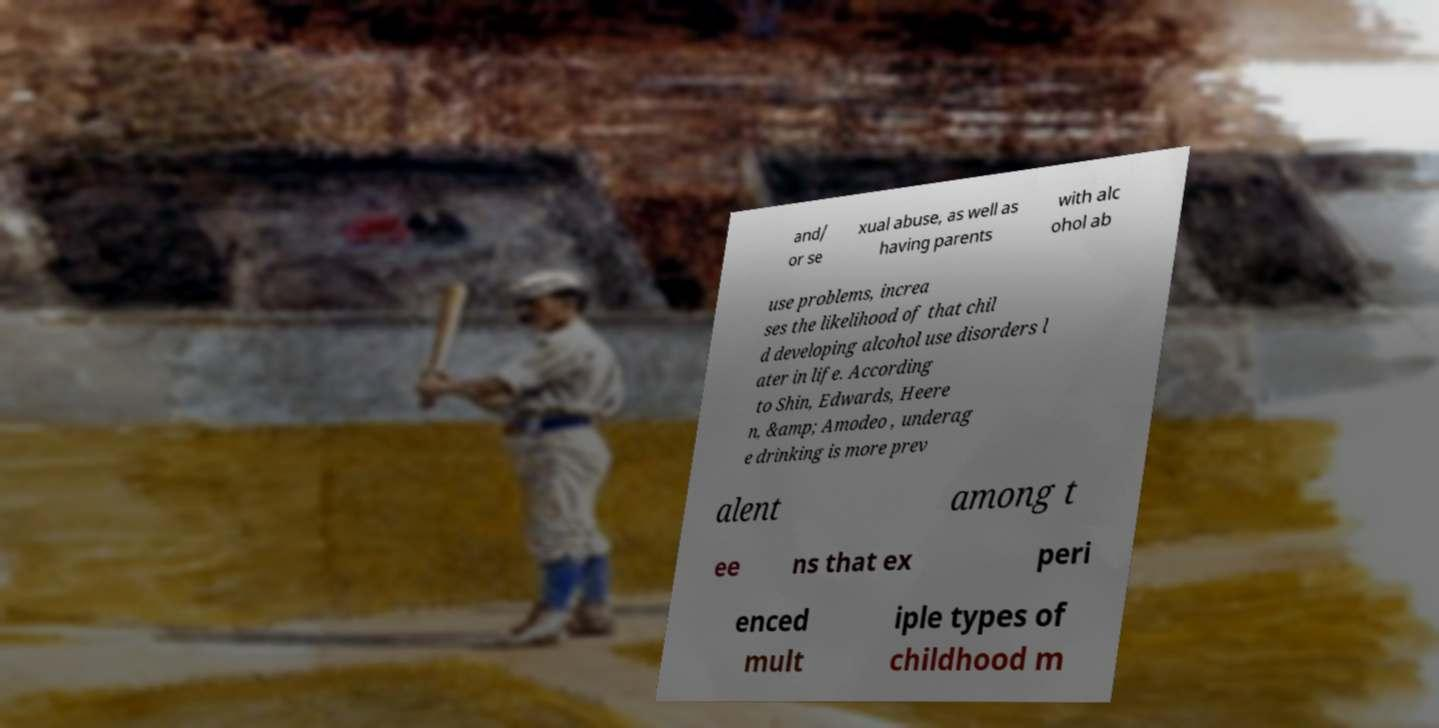What messages or text are displayed in this image? I need them in a readable, typed format. and/ or se xual abuse, as well as having parents with alc ohol ab use problems, increa ses the likelihood of that chil d developing alcohol use disorders l ater in life. According to Shin, Edwards, Heere n, &amp; Amodeo , underag e drinking is more prev alent among t ee ns that ex peri enced mult iple types of childhood m 